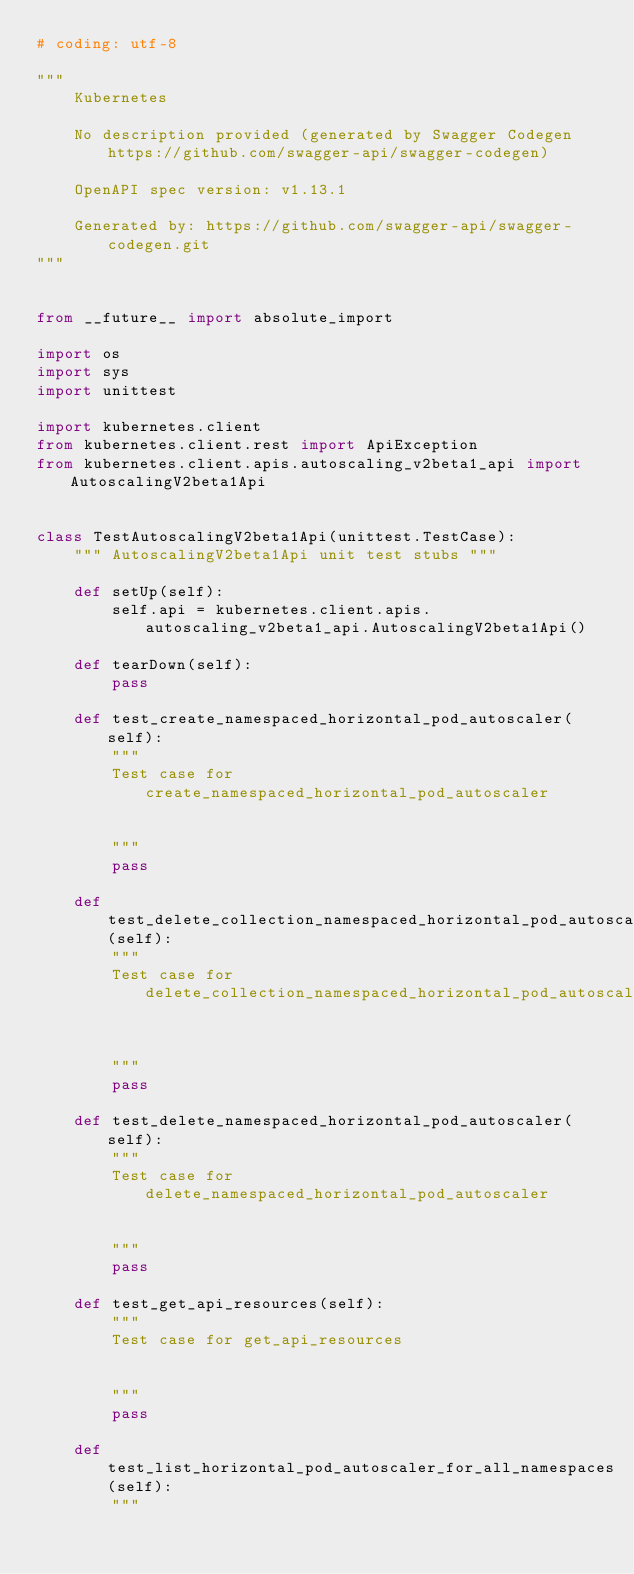Convert code to text. <code><loc_0><loc_0><loc_500><loc_500><_Python_># coding: utf-8

"""
    Kubernetes

    No description provided (generated by Swagger Codegen https://github.com/swagger-api/swagger-codegen)

    OpenAPI spec version: v1.13.1
    
    Generated by: https://github.com/swagger-api/swagger-codegen.git
"""


from __future__ import absolute_import

import os
import sys
import unittest

import kubernetes.client
from kubernetes.client.rest import ApiException
from kubernetes.client.apis.autoscaling_v2beta1_api import AutoscalingV2beta1Api


class TestAutoscalingV2beta1Api(unittest.TestCase):
    """ AutoscalingV2beta1Api unit test stubs """

    def setUp(self):
        self.api = kubernetes.client.apis.autoscaling_v2beta1_api.AutoscalingV2beta1Api()

    def tearDown(self):
        pass

    def test_create_namespaced_horizontal_pod_autoscaler(self):
        """
        Test case for create_namespaced_horizontal_pod_autoscaler

        
        """
        pass

    def test_delete_collection_namespaced_horizontal_pod_autoscaler(self):
        """
        Test case for delete_collection_namespaced_horizontal_pod_autoscaler

        
        """
        pass

    def test_delete_namespaced_horizontal_pod_autoscaler(self):
        """
        Test case for delete_namespaced_horizontal_pod_autoscaler

        
        """
        pass

    def test_get_api_resources(self):
        """
        Test case for get_api_resources

        
        """
        pass

    def test_list_horizontal_pod_autoscaler_for_all_namespaces(self):
        """</code> 